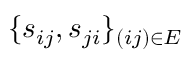Convert formula to latex. <formula><loc_0><loc_0><loc_500><loc_500>\{ s _ { i j } , s _ { j i } \} _ { ( i j ) \in E }</formula> 